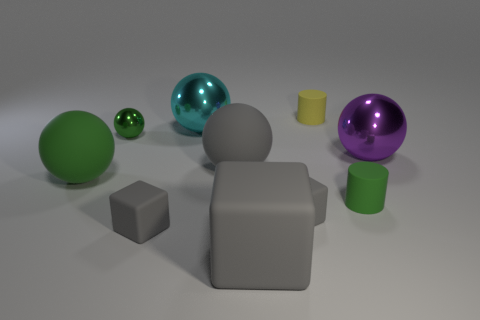There is a small object that is on the left side of the cyan metallic sphere and in front of the big green ball; what is its color? The color of the small object situated on the left side of the cyan metallic sphere and in front of the larger green ball appears to be gray. 